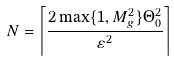<formula> <loc_0><loc_0><loc_500><loc_500>N = \left \lceil \frac { 2 \max \{ 1 , M _ { g } ^ { 2 } \} \Theta _ { 0 } ^ { 2 } } { \varepsilon ^ { 2 } } \right \rceil</formula> 